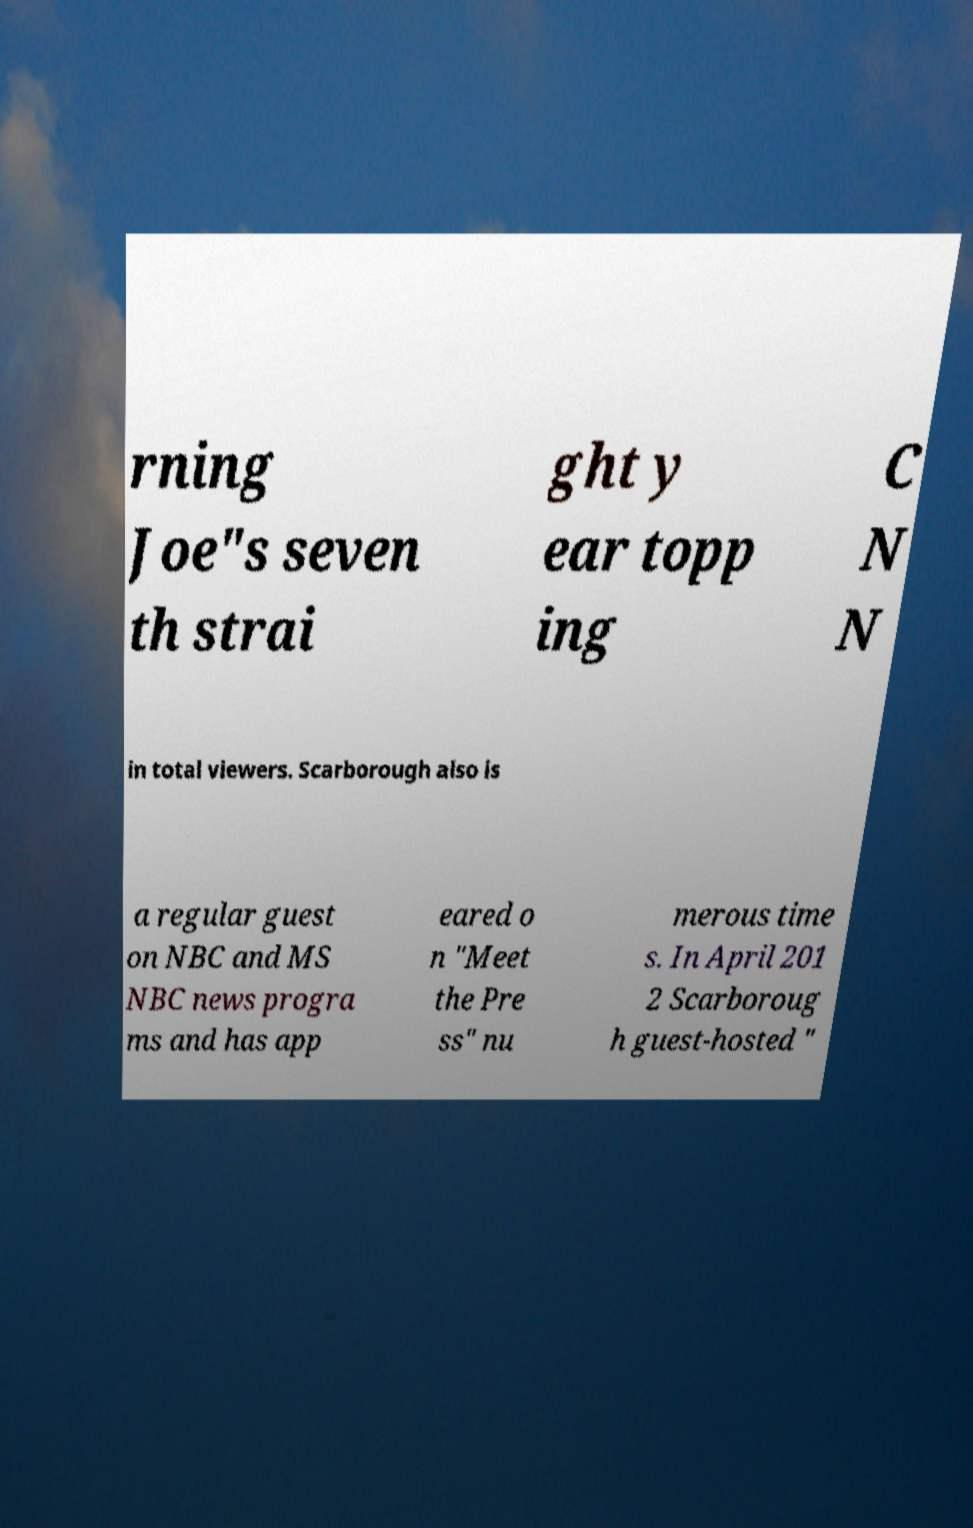Can you read and provide the text displayed in the image?This photo seems to have some interesting text. Can you extract and type it out for me? rning Joe"s seven th strai ght y ear topp ing C N N in total viewers. Scarborough also is a regular guest on NBC and MS NBC news progra ms and has app eared o n "Meet the Pre ss" nu merous time s. In April 201 2 Scarboroug h guest-hosted " 